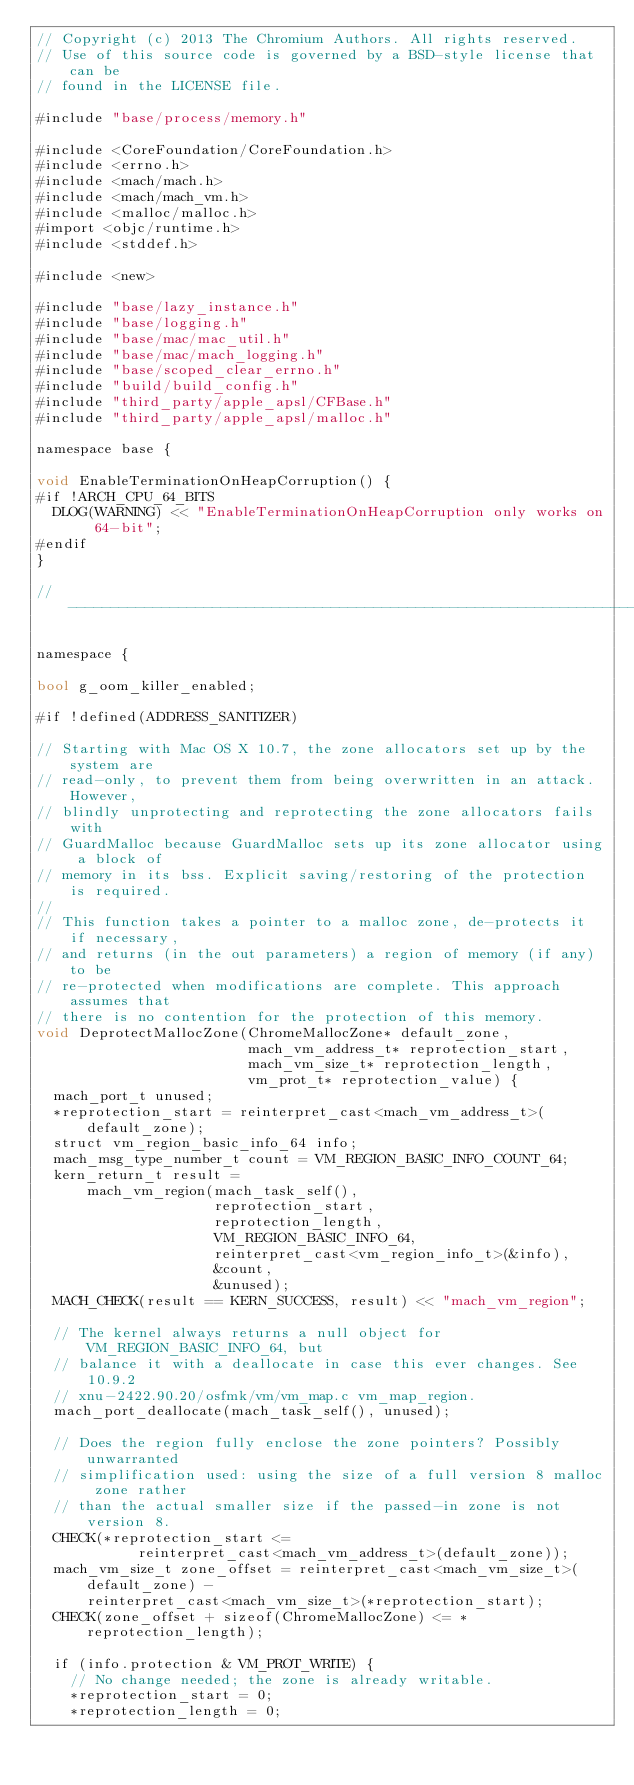<code> <loc_0><loc_0><loc_500><loc_500><_ObjectiveC_>// Copyright (c) 2013 The Chromium Authors. All rights reserved.
// Use of this source code is governed by a BSD-style license that can be
// found in the LICENSE file.

#include "base/process/memory.h"

#include <CoreFoundation/CoreFoundation.h>
#include <errno.h>
#include <mach/mach.h>
#include <mach/mach_vm.h>
#include <malloc/malloc.h>
#import <objc/runtime.h>
#include <stddef.h>

#include <new>

#include "base/lazy_instance.h"
#include "base/logging.h"
#include "base/mac/mac_util.h"
#include "base/mac/mach_logging.h"
#include "base/scoped_clear_errno.h"
#include "build/build_config.h"
#include "third_party/apple_apsl/CFBase.h"
#include "third_party/apple_apsl/malloc.h"

namespace base {

void EnableTerminationOnHeapCorruption() {
#if !ARCH_CPU_64_BITS
  DLOG(WARNING) << "EnableTerminationOnHeapCorruption only works on 64-bit";
#endif
}

// ------------------------------------------------------------------------

namespace {

bool g_oom_killer_enabled;

#if !defined(ADDRESS_SANITIZER)

// Starting with Mac OS X 10.7, the zone allocators set up by the system are
// read-only, to prevent them from being overwritten in an attack. However,
// blindly unprotecting and reprotecting the zone allocators fails with
// GuardMalloc because GuardMalloc sets up its zone allocator using a block of
// memory in its bss. Explicit saving/restoring of the protection is required.
//
// This function takes a pointer to a malloc zone, de-protects it if necessary,
// and returns (in the out parameters) a region of memory (if any) to be
// re-protected when modifications are complete. This approach assumes that
// there is no contention for the protection of this memory.
void DeprotectMallocZone(ChromeMallocZone* default_zone,
                         mach_vm_address_t* reprotection_start,
                         mach_vm_size_t* reprotection_length,
                         vm_prot_t* reprotection_value) {
  mach_port_t unused;
  *reprotection_start = reinterpret_cast<mach_vm_address_t>(default_zone);
  struct vm_region_basic_info_64 info;
  mach_msg_type_number_t count = VM_REGION_BASIC_INFO_COUNT_64;
  kern_return_t result =
      mach_vm_region(mach_task_self(),
                     reprotection_start,
                     reprotection_length,
                     VM_REGION_BASIC_INFO_64,
                     reinterpret_cast<vm_region_info_t>(&info),
                     &count,
                     &unused);
  MACH_CHECK(result == KERN_SUCCESS, result) << "mach_vm_region";

  // The kernel always returns a null object for VM_REGION_BASIC_INFO_64, but
  // balance it with a deallocate in case this ever changes. See 10.9.2
  // xnu-2422.90.20/osfmk/vm/vm_map.c vm_map_region.
  mach_port_deallocate(mach_task_self(), unused);

  // Does the region fully enclose the zone pointers? Possibly unwarranted
  // simplification used: using the size of a full version 8 malloc zone rather
  // than the actual smaller size if the passed-in zone is not version 8.
  CHECK(*reprotection_start <=
            reinterpret_cast<mach_vm_address_t>(default_zone));
  mach_vm_size_t zone_offset = reinterpret_cast<mach_vm_size_t>(default_zone) -
      reinterpret_cast<mach_vm_size_t>(*reprotection_start);
  CHECK(zone_offset + sizeof(ChromeMallocZone) <= *reprotection_length);

  if (info.protection & VM_PROT_WRITE) {
    // No change needed; the zone is already writable.
    *reprotection_start = 0;
    *reprotection_length = 0;</code> 